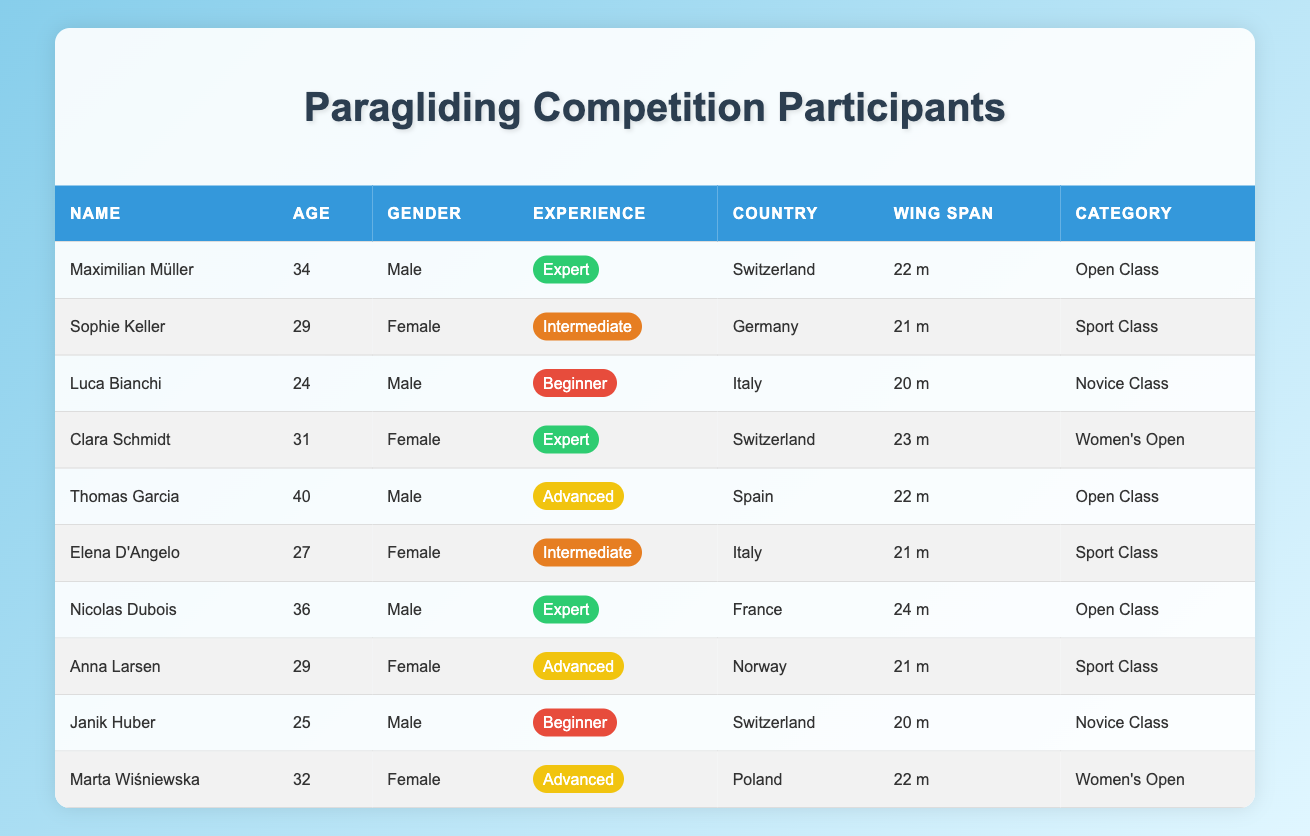What is the wing span of Maximilian Müller? By looking at the row corresponding to Maximilian Müller, we can see the "Wing Span" column, which lists his wing span as "22 m."
Answer: 22 m How many male participants are there? By scanning the "Gender" column, we can count the number of males, which are Maximilian Müller, Luca Bianchi, Thomas Garcia, Nicolas Dubois, and Janik Huber. That gives a total of 5 male participants.
Answer: 5 What is the age of the oldest participant? Checking the "Age" column for maximum values, we find Thomas Garcia is 40 years old. He is the oldest participant.
Answer: 40 Which competition category has the most participants? By examining the "Competition Category" column, the categories are: Open Class (3), Sport Class (4), Novice Class (2), and Women's Open (2). Sport Class has the highest count at 4 participants.
Answer: Sport Class Is there any female participant with a wing span greater than 22 m? By looking through the female participants, Clara Schmidt has a wing span of 23 m, which is greater than 22 m. Thus, the answer is yes.
Answer: Yes What is the average age of all participants in the table? We sum the ages: 34 + 29 + 24 + 31 + 40 + 27 + 36 + 29 + 25 + 32 =  359. There are 10 participants, so the average age is 359/10 = 35.9.
Answer: 35.9 How many participants from Switzerland have an experience level of "Expert"? We can find that Maximilian Müller and Clara Schmidt are both from Switzerland and have an experience level of "Expert," totaling 2 participants.
Answer: 2 Do all participants in the "Novice Class" have a wing span of less than 22 m? Checking the "Novice Class," both participants, Luca Bianchi and Janik Huber, have wing spans of 20 m each, which is less than 22 m. Thus, the answer is yes.
Answer: Yes Which gender has a higher proportion of "Advanced" experience level among the participants? From the table, we see there are 2 female participants (Anna Larsen and Marta Wiśniewska) and 1 male participant (Thomas Garcia) at the "Advanced" level. Since there are 5 males in total, the proportion for males is 1/5 = 0.2 and for females is 2/5 = 0.4. Therefore, females have a higher proportion.
Answer: Female 